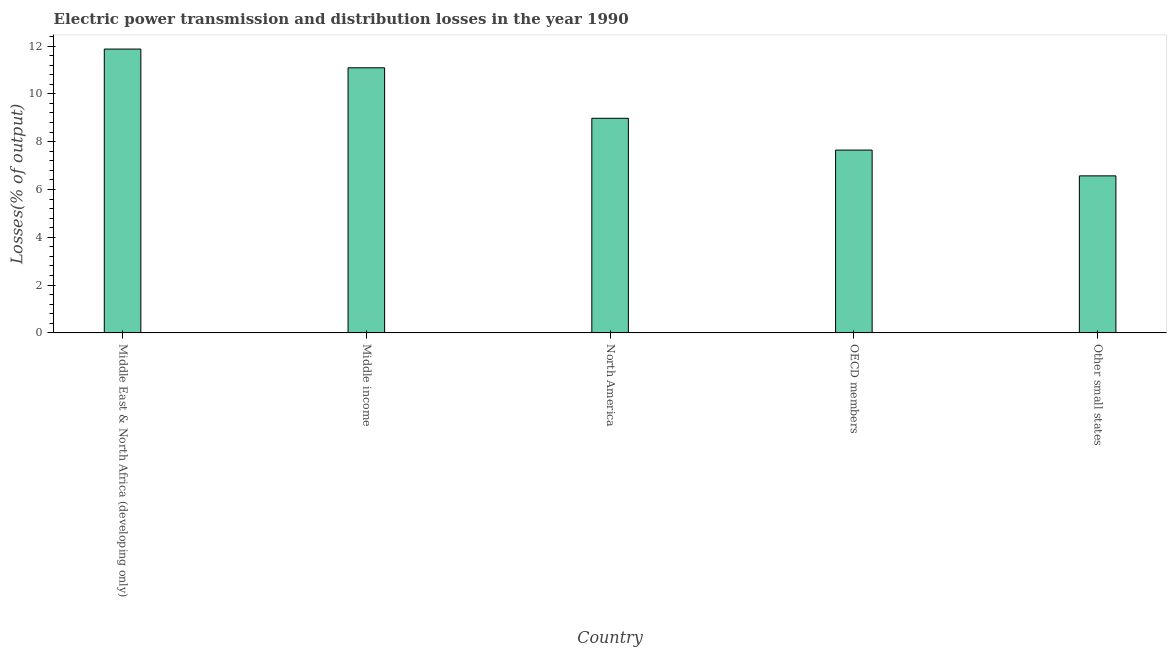Does the graph contain grids?
Your response must be concise. No. What is the title of the graph?
Give a very brief answer. Electric power transmission and distribution losses in the year 1990. What is the label or title of the X-axis?
Provide a short and direct response. Country. What is the label or title of the Y-axis?
Your response must be concise. Losses(% of output). What is the electric power transmission and distribution losses in North America?
Offer a terse response. 8.98. Across all countries, what is the maximum electric power transmission and distribution losses?
Your answer should be compact. 11.87. Across all countries, what is the minimum electric power transmission and distribution losses?
Ensure brevity in your answer.  6.57. In which country was the electric power transmission and distribution losses maximum?
Offer a very short reply. Middle East & North Africa (developing only). In which country was the electric power transmission and distribution losses minimum?
Provide a succinct answer. Other small states. What is the sum of the electric power transmission and distribution losses?
Your response must be concise. 46.16. What is the difference between the electric power transmission and distribution losses in Middle income and Other small states?
Give a very brief answer. 4.52. What is the average electric power transmission and distribution losses per country?
Make the answer very short. 9.23. What is the median electric power transmission and distribution losses?
Ensure brevity in your answer.  8.98. In how many countries, is the electric power transmission and distribution losses greater than 9.6 %?
Offer a terse response. 2. What is the ratio of the electric power transmission and distribution losses in Middle East & North Africa (developing only) to that in OECD members?
Your answer should be compact. 1.55. What is the difference between the highest and the second highest electric power transmission and distribution losses?
Ensure brevity in your answer.  0.78. Is the sum of the electric power transmission and distribution losses in North America and OECD members greater than the maximum electric power transmission and distribution losses across all countries?
Give a very brief answer. Yes. What is the difference between the highest and the lowest electric power transmission and distribution losses?
Your answer should be compact. 5.3. How many bars are there?
Your response must be concise. 5. How many countries are there in the graph?
Give a very brief answer. 5. What is the difference between two consecutive major ticks on the Y-axis?
Keep it short and to the point. 2. Are the values on the major ticks of Y-axis written in scientific E-notation?
Your answer should be compact. No. What is the Losses(% of output) in Middle East & North Africa (developing only)?
Your answer should be very brief. 11.87. What is the Losses(% of output) in Middle income?
Your answer should be very brief. 11.09. What is the Losses(% of output) of North America?
Your answer should be compact. 8.98. What is the Losses(% of output) of OECD members?
Offer a terse response. 7.65. What is the Losses(% of output) in Other small states?
Provide a short and direct response. 6.57. What is the difference between the Losses(% of output) in Middle East & North Africa (developing only) and Middle income?
Offer a terse response. 0.78. What is the difference between the Losses(% of output) in Middle East & North Africa (developing only) and North America?
Offer a very short reply. 2.9. What is the difference between the Losses(% of output) in Middle East & North Africa (developing only) and OECD members?
Your response must be concise. 4.22. What is the difference between the Losses(% of output) in Middle East & North Africa (developing only) and Other small states?
Provide a succinct answer. 5.3. What is the difference between the Losses(% of output) in Middle income and North America?
Give a very brief answer. 2.11. What is the difference between the Losses(% of output) in Middle income and OECD members?
Your answer should be very brief. 3.44. What is the difference between the Losses(% of output) in Middle income and Other small states?
Your response must be concise. 4.52. What is the difference between the Losses(% of output) in North America and OECD members?
Provide a short and direct response. 1.33. What is the difference between the Losses(% of output) in North America and Other small states?
Your response must be concise. 2.41. What is the difference between the Losses(% of output) in OECD members and Other small states?
Your response must be concise. 1.08. What is the ratio of the Losses(% of output) in Middle East & North Africa (developing only) to that in Middle income?
Offer a terse response. 1.07. What is the ratio of the Losses(% of output) in Middle East & North Africa (developing only) to that in North America?
Your response must be concise. 1.32. What is the ratio of the Losses(% of output) in Middle East & North Africa (developing only) to that in OECD members?
Keep it short and to the point. 1.55. What is the ratio of the Losses(% of output) in Middle East & North Africa (developing only) to that in Other small states?
Your answer should be compact. 1.81. What is the ratio of the Losses(% of output) in Middle income to that in North America?
Your response must be concise. 1.24. What is the ratio of the Losses(% of output) in Middle income to that in OECD members?
Provide a succinct answer. 1.45. What is the ratio of the Losses(% of output) in Middle income to that in Other small states?
Ensure brevity in your answer.  1.69. What is the ratio of the Losses(% of output) in North America to that in OECD members?
Keep it short and to the point. 1.17. What is the ratio of the Losses(% of output) in North America to that in Other small states?
Provide a short and direct response. 1.37. What is the ratio of the Losses(% of output) in OECD members to that in Other small states?
Ensure brevity in your answer.  1.16. 